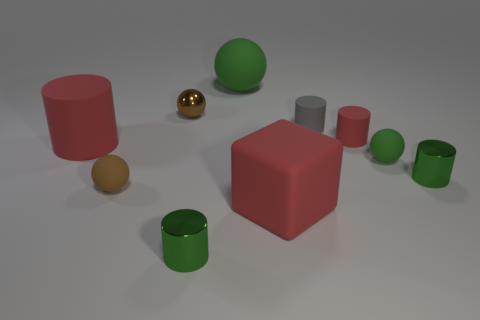Subtract all gray cylinders. How many cylinders are left? 4 Subtract all big rubber cylinders. How many cylinders are left? 4 Subtract all cyan cylinders. Subtract all yellow balls. How many cylinders are left? 5 Subtract all cubes. How many objects are left? 9 Subtract 1 red blocks. How many objects are left? 9 Subtract all large spheres. Subtract all small cylinders. How many objects are left? 5 Add 1 metallic spheres. How many metallic spheres are left? 2 Add 2 red objects. How many red objects exist? 5 